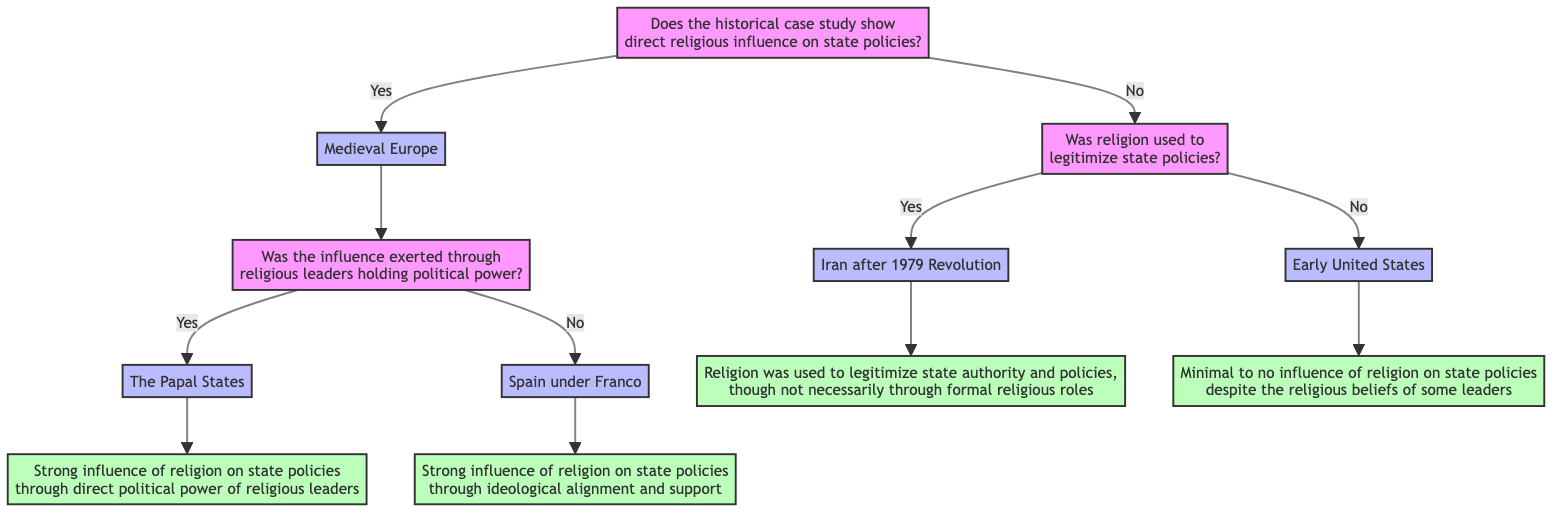Does the historical case study show direct religious influence on state policies? This is the initial question in the decision tree. The response will lead to either "Yes" with further branching or "No" leading to another question regarding the legitimacy of state policies.
Answer: Yes What case study is associated with the "Yes" answer to the first question? Following the "Yes" answer to the first question, the diagram immediately identifies "Medieval Europe" as the case study for this branch.
Answer: Medieval Europe What question follows after identifying "Medieval Europe"? The flowchart specifies that after selecting "Medieval Europe," the next question is regarding whether the influence was exerted through religious leaders holding political power, leading further into the decision tree.
Answer: Was the influence exerted through religious leaders holding political power? What conclusion is drawn from "The Papal States"? The diagram states that if the influence was indeed through political power of religious leaders, the conclusion is the strong influence of religion on state policies through the direct political power of religious leaders.
Answer: Strong influence of religion on state policies through direct political power of religious leaders What case study reflects the "No" answer to direct religious influence on state policies? The tree designates that if the first question is answered "No," the relevant case study is "Early United States," indicating minimal to no influence of religion despite some leaders' beliefs.
Answer: Early United States What is the conclusion for the case study "Iran after 1979 Revolution"? The diagram concludes that in this case, religion was utilized to legitimize state authority and policies, even without formal religious roles being present.
Answer: Religion was used to legitimize state authority and policies, though not necessarily through formal religious roles How many outcomes directly relate to the "Yes" branch under the question about direct religious influence? The diagram offers two outcomes linked to the "Yes" branch: "The Papal States" and "Spain under Franco," leading to conclusions about direct influence or ideological support.
Answer: Two outcomes What leads to the question regarding legitimization of state policies? If the initial question about direct religious influence is answered "No," it directly branches into the next question asking if religion was used to legitimize state policies.
Answer: The answer "No" to direct influence leads to this question 